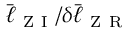<formula> <loc_0><loc_0><loc_500><loc_500>\bar { \ell } _ { Z I } / \delta \bar { \ell } _ { Z R }</formula> 